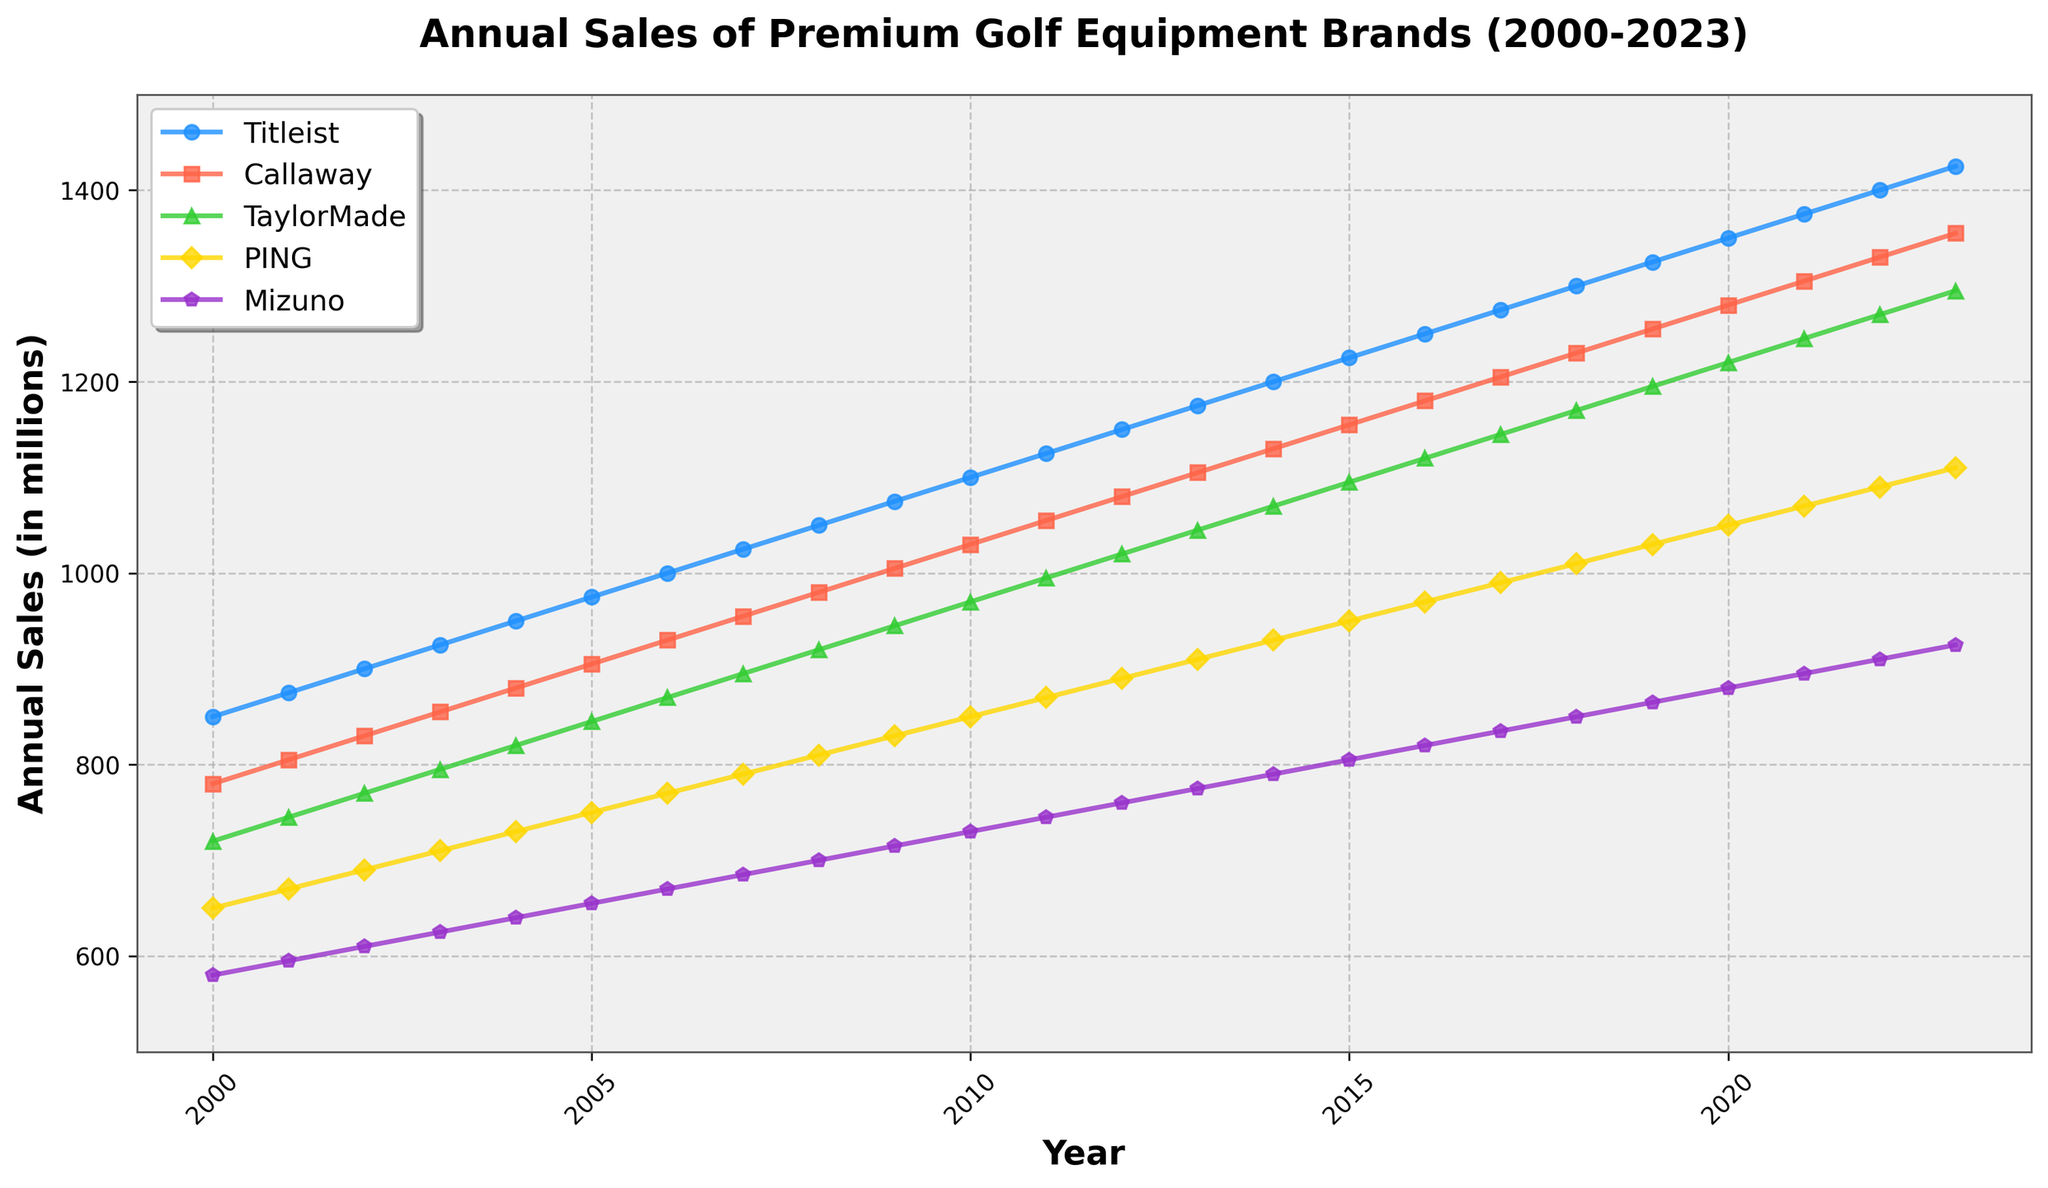What is the general trend in the annual sales for Titleist from 2000 to 2023? By examining the line for Titleist, we can see that it starts at 850 in 2000 and increases consistently to 1425 by 2023. This indicates a generally increasing trend in annual sales.
Answer: Increasing Which brand had the highest annual sales in 2010? By comparing the points on the lines for each brand in the year 2010, we can see that Titleist has the highest value at 1100.
Answer: Titleist What is the difference in annual sales between Callaway and TaylorMade in 2023? Locate the points for Callaway and TaylorMade in 2023. The values are 1355 for Callaway and 1295 for TaylorMade. Subtract 1295 from 1355.
Answer: 60 Which brand showed the smallest growth in annual sales from 2000 to 2023? To determine this, calculate the difference in sales from 2000 to 2023 for each brand. The smallest difference is for Mizuno, which increased from 580 to 925, a difference of 345.
Answer: Mizuno By how much did the annual sales for PING increase from 2000 to 2023? Find the value for PING in 2000 (650) and in 2023 (1110). Subtract 650 from 1110.
Answer: 460 In which year did TaylorMade’s annual sales reach 1000? Follow the line for TaylorMade and find the year where the sales are closest to 1000. It reaches 995 in 2011 and 1020 in 2012. So, it’s in 2012 that it first reaches or surpasses 1000.
Answer: 2012 Which two brands had the closest annual sales in 2005? Compare the values for each brand in 2005. Callaway had 905 and TaylorMade had 845. The difference is 905 - 845 = 60. This is the smallest difference among all brands in that year.
Answer: Callaway and TaylorMade What is the average annual sales of calls among all brands in the year 2020? Sum up the annual sales for all brands in 2020 (1350 + 1280 + 1220 + 1050 + 880 = 6780). Then divide by the number of brands (5). 6780 / 5 = 1356.
Answer: 1356 By how much did annual sales for Mizuno increase between 2010 and 2020? Find the value of sales for Mizuno in 2010 (730) and in 2020 (880). Subtract 730 from 880.
Answer: 150 What is the color and shape used to depict TaylorMade in the plot? By referring to the legend in the plot, TaylorMade is represented by a green line with triangle markers.
Answer: Green, triangle 